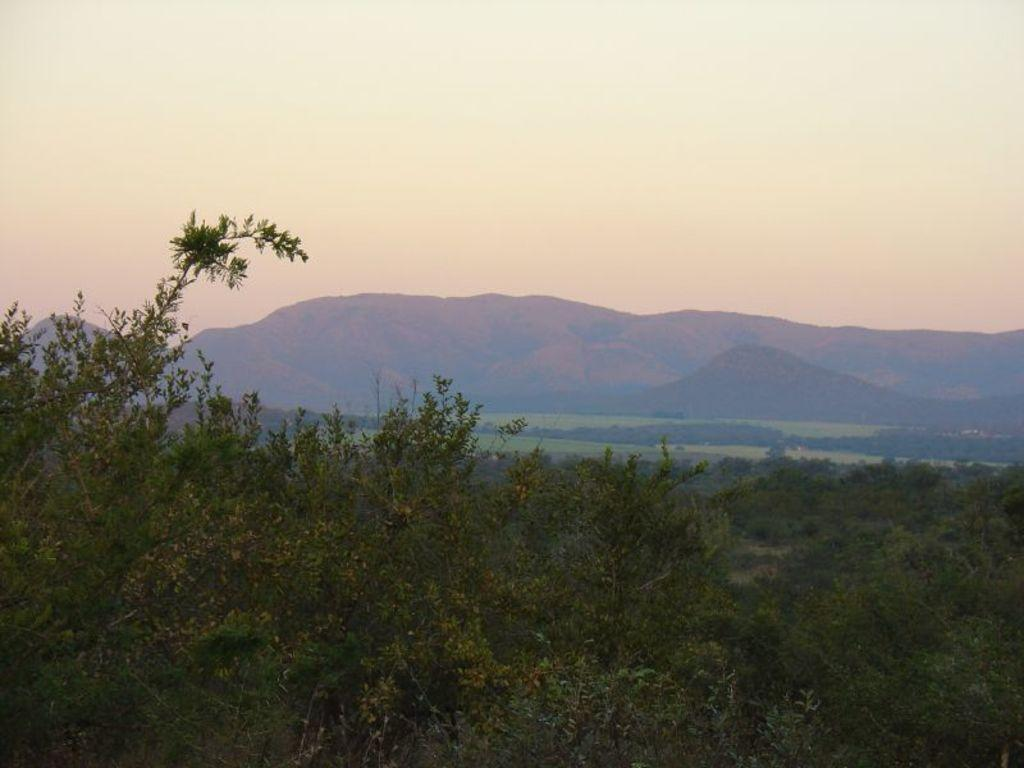What type of vegetation is in the foreground of the image? There are trees in the foreground of the image. What geographical features can be seen in the middle of the image? There are hills in the middle of the image. What type of landscape is present in the middle of the image? There is greenery in the middle of the image. What is visible at the top of the image? The sky is visible at the top of the image. Can you tell me how many bananas the monkey is holding in the image? There is no monkey or bananas present in the image. What is the tendency of the greenery in the image? The provided facts do not mention any tendencies of the greenery; it is simply present in the image. 